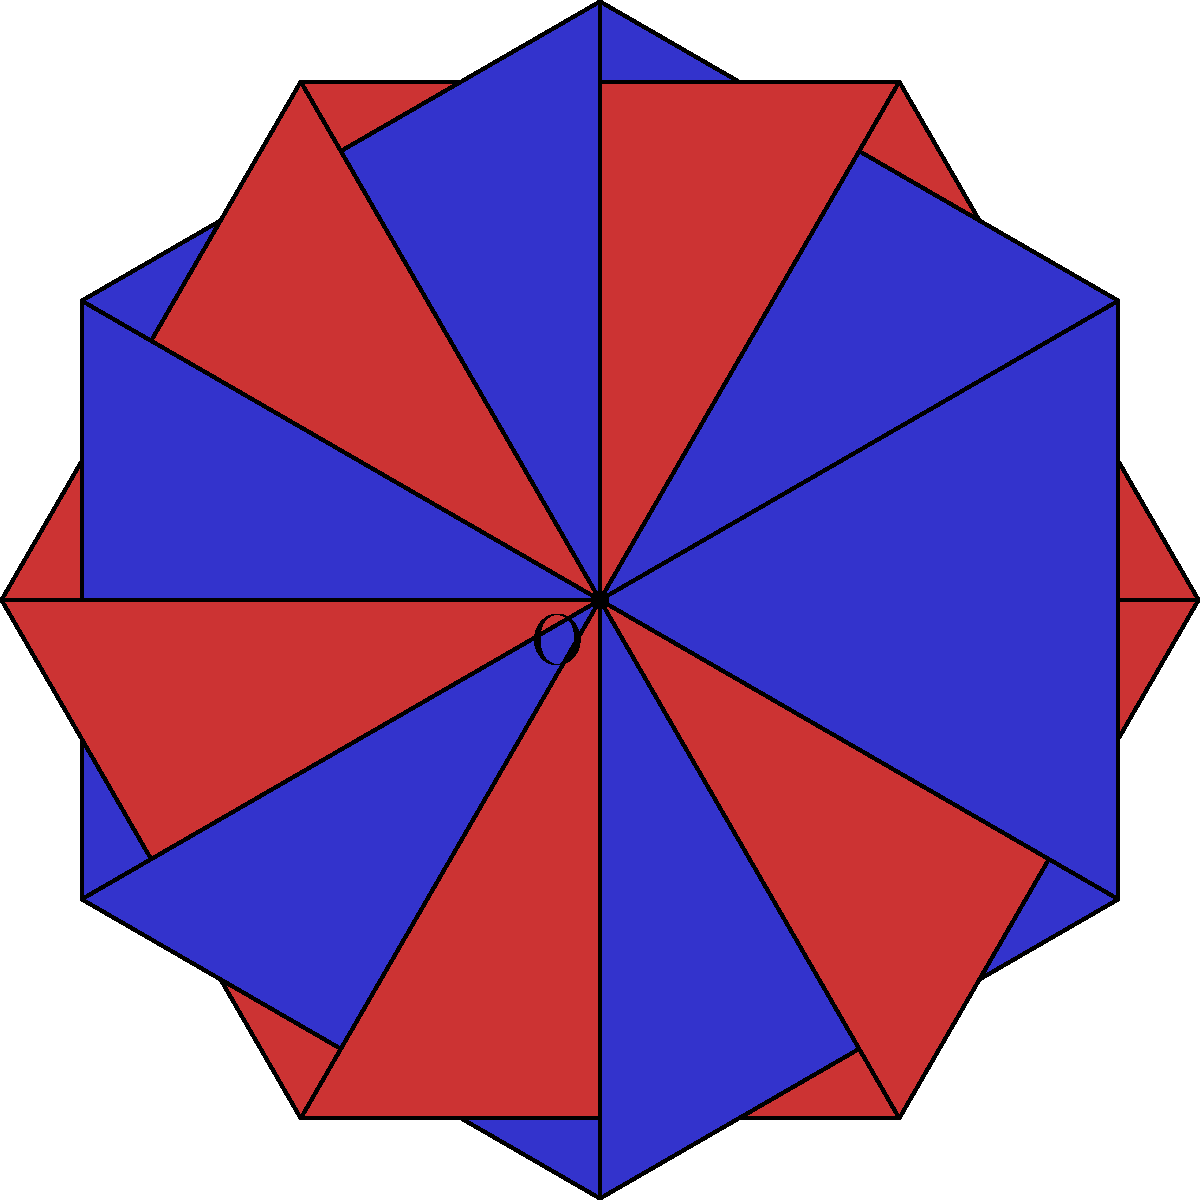As a beta tester examining a new geometric modeling software, you encounter a tessellation pattern of alternating red and blue equilateral triangles arranged around a central point O. The pattern completes a full rotation in 6 steps. If the software allows for precise rotational transformations, what is the minimum angle of rotation needed to map a red triangle onto the position of its adjacent blue triangle? Let's approach this step-by-step:

1) First, we need to analyze the pattern:
   - There are 12 triangles in total: 6 red and 6 blue.
   - They form a complete 360° rotation around point O.

2) We can calculate the angle each triangle occupies:
   $\frac{360°}{12} = 30°$

3) We observe that each red triangle is followed by a blue triangle, and vice versa.

4) To map a red triangle onto the position of its adjacent blue triangle, we need to rotate by the angle that separates their centers.

5) The centers of adjacent triangles are separated by one triangle's width, which we calculated to be 30°.

6) Therefore, the minimum angle of rotation needed is 30°.

This rotation would perfectly align a red triangle with the position of its neighboring blue triangle, demonstrating the software's precision in geometric transformations.
Answer: 30° 